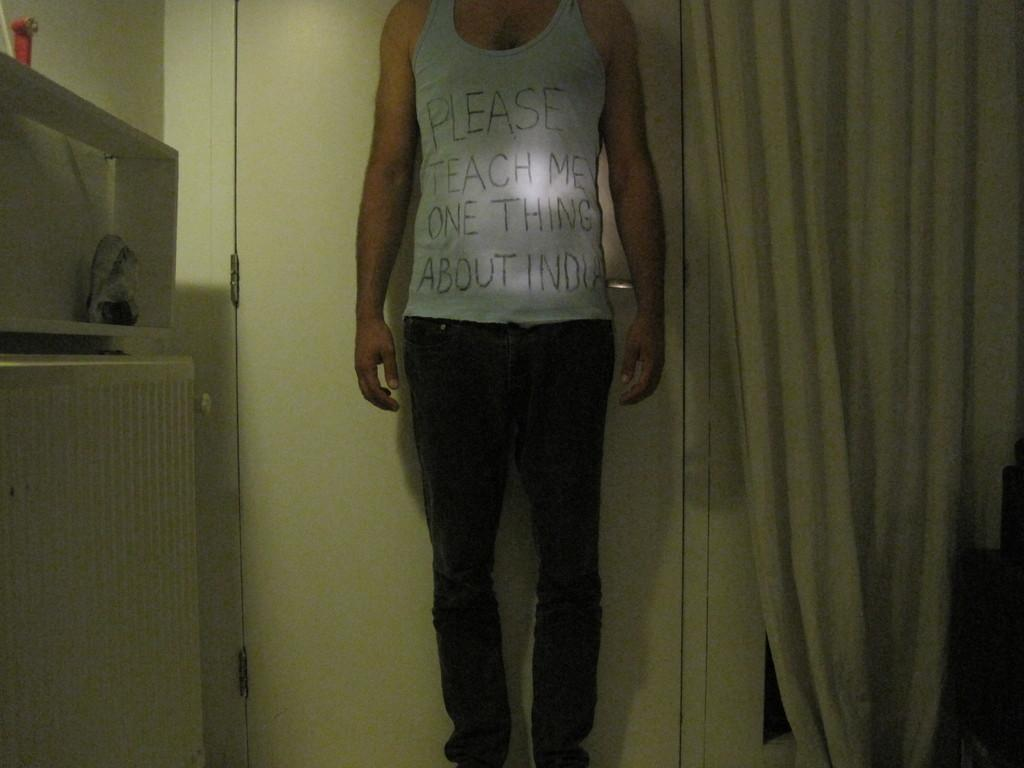Who is present in the image? There is a man in the image. What is the man wearing? The man is wearing a sleeveless white shirt. What can be seen to the right of the man? There is a curtain to the right of the man. What is located behind the man? There is a door behind the man. What is on the wall to the left of the man? There is a wall with a cupboard to the left of the man. Can you see the man's leg in the ocean in the image? There is no ocean present in the image, and the man's leg is not visible. 